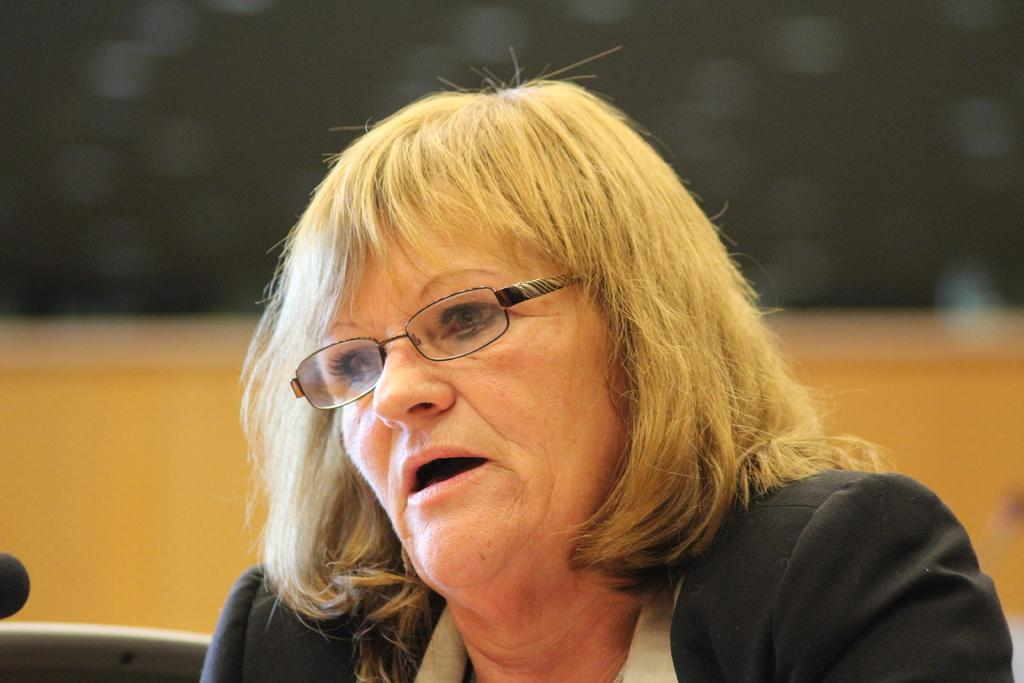What is the main subject of the image? There is a person in the image. What is the person wearing? The person is wearing a white and black color dress. Are there any accessories visible on the person? Yes, the person is wearing specs. How would you describe the background of the image? The background of the image is blurred. What type of creature is the person's father in the image? There is no creature or father mentioned in the image; it only features a person wearing a dress and specs with a blurred background. 